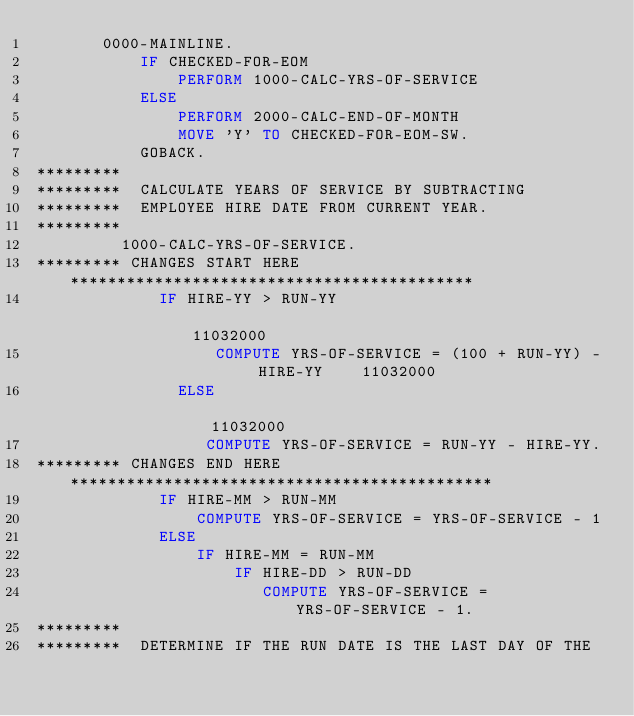Convert code to text. <code><loc_0><loc_0><loc_500><loc_500><_COBOL_>       0000-MAINLINE.
           IF CHECKED-FOR-EOM
               PERFORM 1000-CALC-YRS-OF-SERVICE
           ELSE
               PERFORM 2000-CALC-END-OF-MONTH
               MOVE 'Y' TO CHECKED-FOR-EOM-SW.
           GOBACK.
*********
*********  CALCULATE YEARS OF SERVICE BY SUBTRACTING
*********  EMPLOYEE HIRE DATE FROM CURRENT YEAR.
*********
         1000-CALC-YRS-OF-SERVICE.
********* CHANGES START HERE *******************************************
             IF HIRE-YY > RUN-YY                                        11032000
                   COMPUTE YRS-OF-SERVICE = (100 + RUN-YY) - HIRE-YY    11032000
               ELSE                                                     11032000
                  COMPUTE YRS-OF-SERVICE = RUN-YY - HIRE-YY.
********* CHANGES END HERE *********************************************
             IF HIRE-MM > RUN-MM
                 COMPUTE YRS-OF-SERVICE = YRS-OF-SERVICE - 1
             ELSE
                 IF HIRE-MM = RUN-MM
                     IF HIRE-DD > RUN-DD
                        COMPUTE YRS-OF-SERVICE = YRS-OF-SERVICE - 1.
*********
*********  DETERMINE IF THE RUN DATE IS THE LAST DAY OF THE</code> 